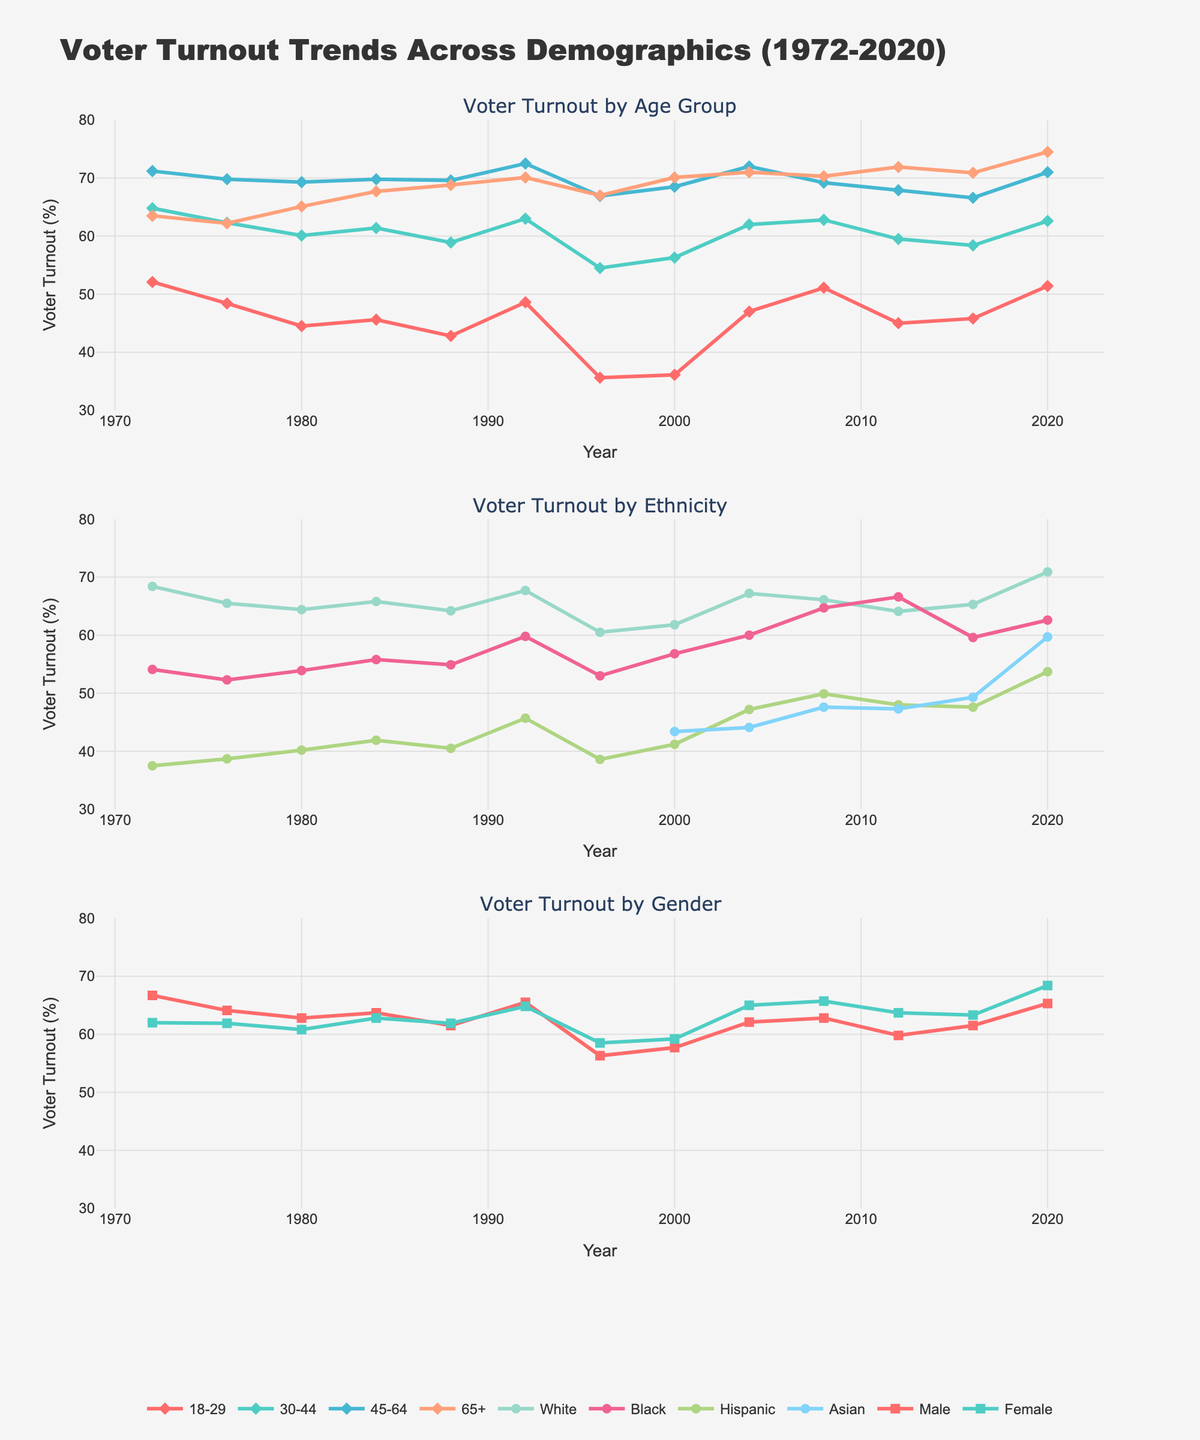What demographic shows the most consistent increase in voter turnout over the years? To determine which demographic shows the most consistent increase, look at each line over the years and see which one has a generally upward trend with the fewest dips. The "65+" age group shows a consistent increase from 63.5% in 1972 to 74.5% in 2020.
Answer: 65+ Which year saw the largest disparity in voter turnout between the 18-29 and 45-64 age groups? Look for the years where the difference between the voter turnout percentages of the 18-29 and 45-64 age groups is the largest. Subtract the 18-29 turnout from the 45-64 turnout for each year and compare. In 1996, the difference is the largest with (66.9% - 35.6%) = 31.3%.
Answer: 1996 How did voter turnout for the Asian demographic change from the year 2000 to 2020? Compare the voter turnout percentages for the Asian demographic in the years 2000 and 2020. In 2000, the turnout was 43.4%, and in 2020 it was 59.7%. Calculate the change as 59.7% - 43.4% = 16.3%.
Answer: Increased by 16.3% What is the combined average voter turnout for the Male and Female demographics in 2008? Add the voter turnout percentages for males and females in 2008 and divide by 2. [(62.8% + 65.7%) / 2] = 64.25%.
Answer: 64.25% Did the voter turnout for the Hispanic demographic ever surpass 50%? If so, in which years? Check the values for the Hispanic demographic throughout the years. The turnout surpassed 50% in 2008 (49.9%), barely missing it. But in 2020, it reached 53.7%.
Answer: 2020 Which demographic shows the greatest variability in voter turnout over the available years? Identify the demographic with the largest range between its highest and lowest voter turnout percentages. The 18-29 age group has a range from 35.6% (1996) to 52.1% (1972), covering a difference of 16.5%. However, the Hispanic demographic is more variable with a range from 37.5% (1972) to 53.7% (2020), totaling 16.2%. The ranges are similar but considering more fluctuations, the 18-29 group can be considered more variable.
Answer: 18-29 In which year did the voter turnout for women first surpass that of men? Compare the voter turnout for men and women for each year. The first year female voter turnout surpasses male voter turnout is 1984, with 62.8% for females and 63.7% for males.
Answer: 1984 What is the rate of increase in voter turnout for the Black demographic from 1972 to 2020? Calculate the difference in the voter turnout percentage for the Black demographic between 1972 and 2020 and divide it by the number of years (2020-1972). Increase = (62.6% - 54.1%) / (2020-1972) = 8.5% / 48 years ≈ 0.177% per year.
Answer: 0.177% per year 